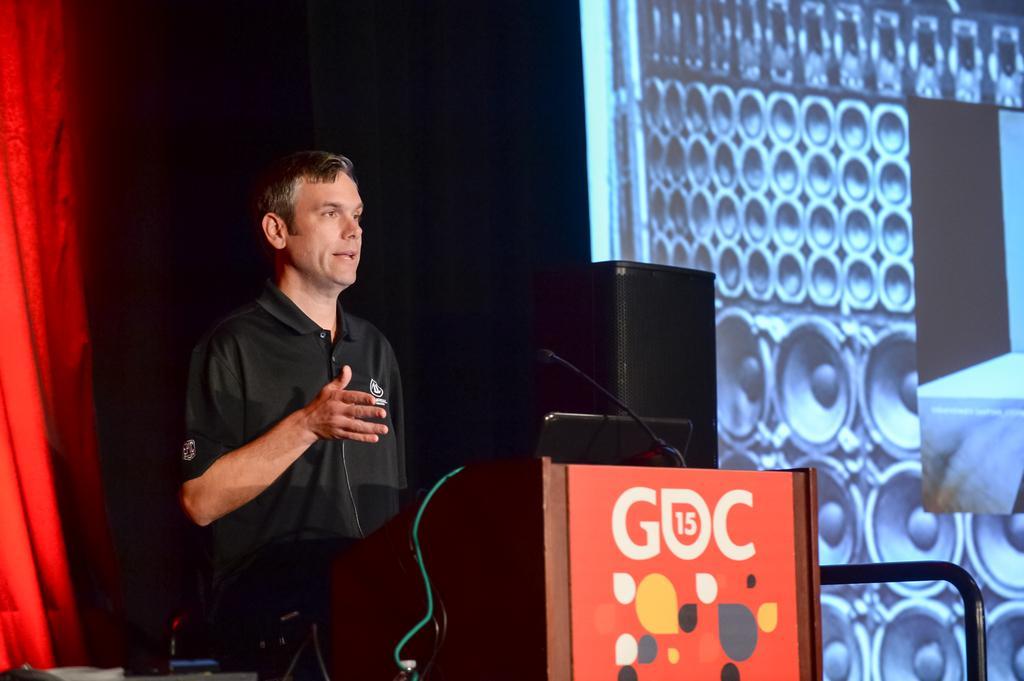Could you give a brief overview of what you see in this image? In-front of this person there is a podium with laptop and mic. Here we can see a red curtain, speaker and screen. 